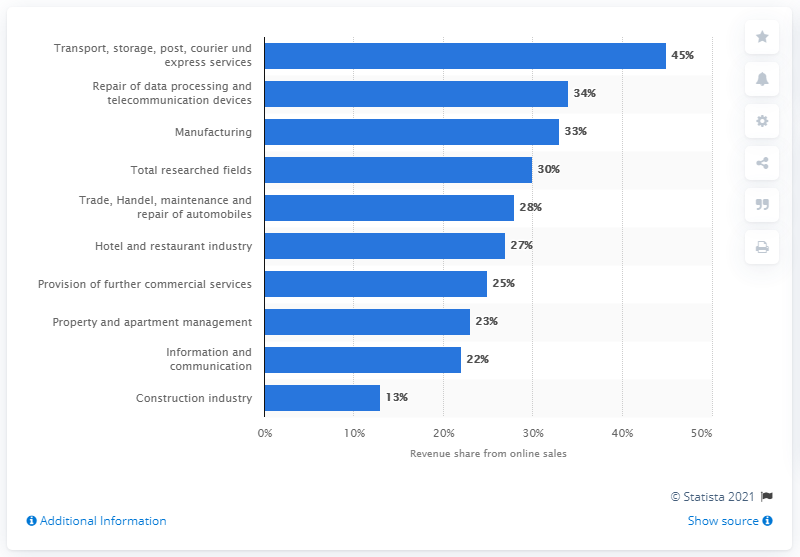Outline some significant characteristics in this image. According to the data, companies from the manufacturing sector generated 33% of their revenue through the internet in the given period. 